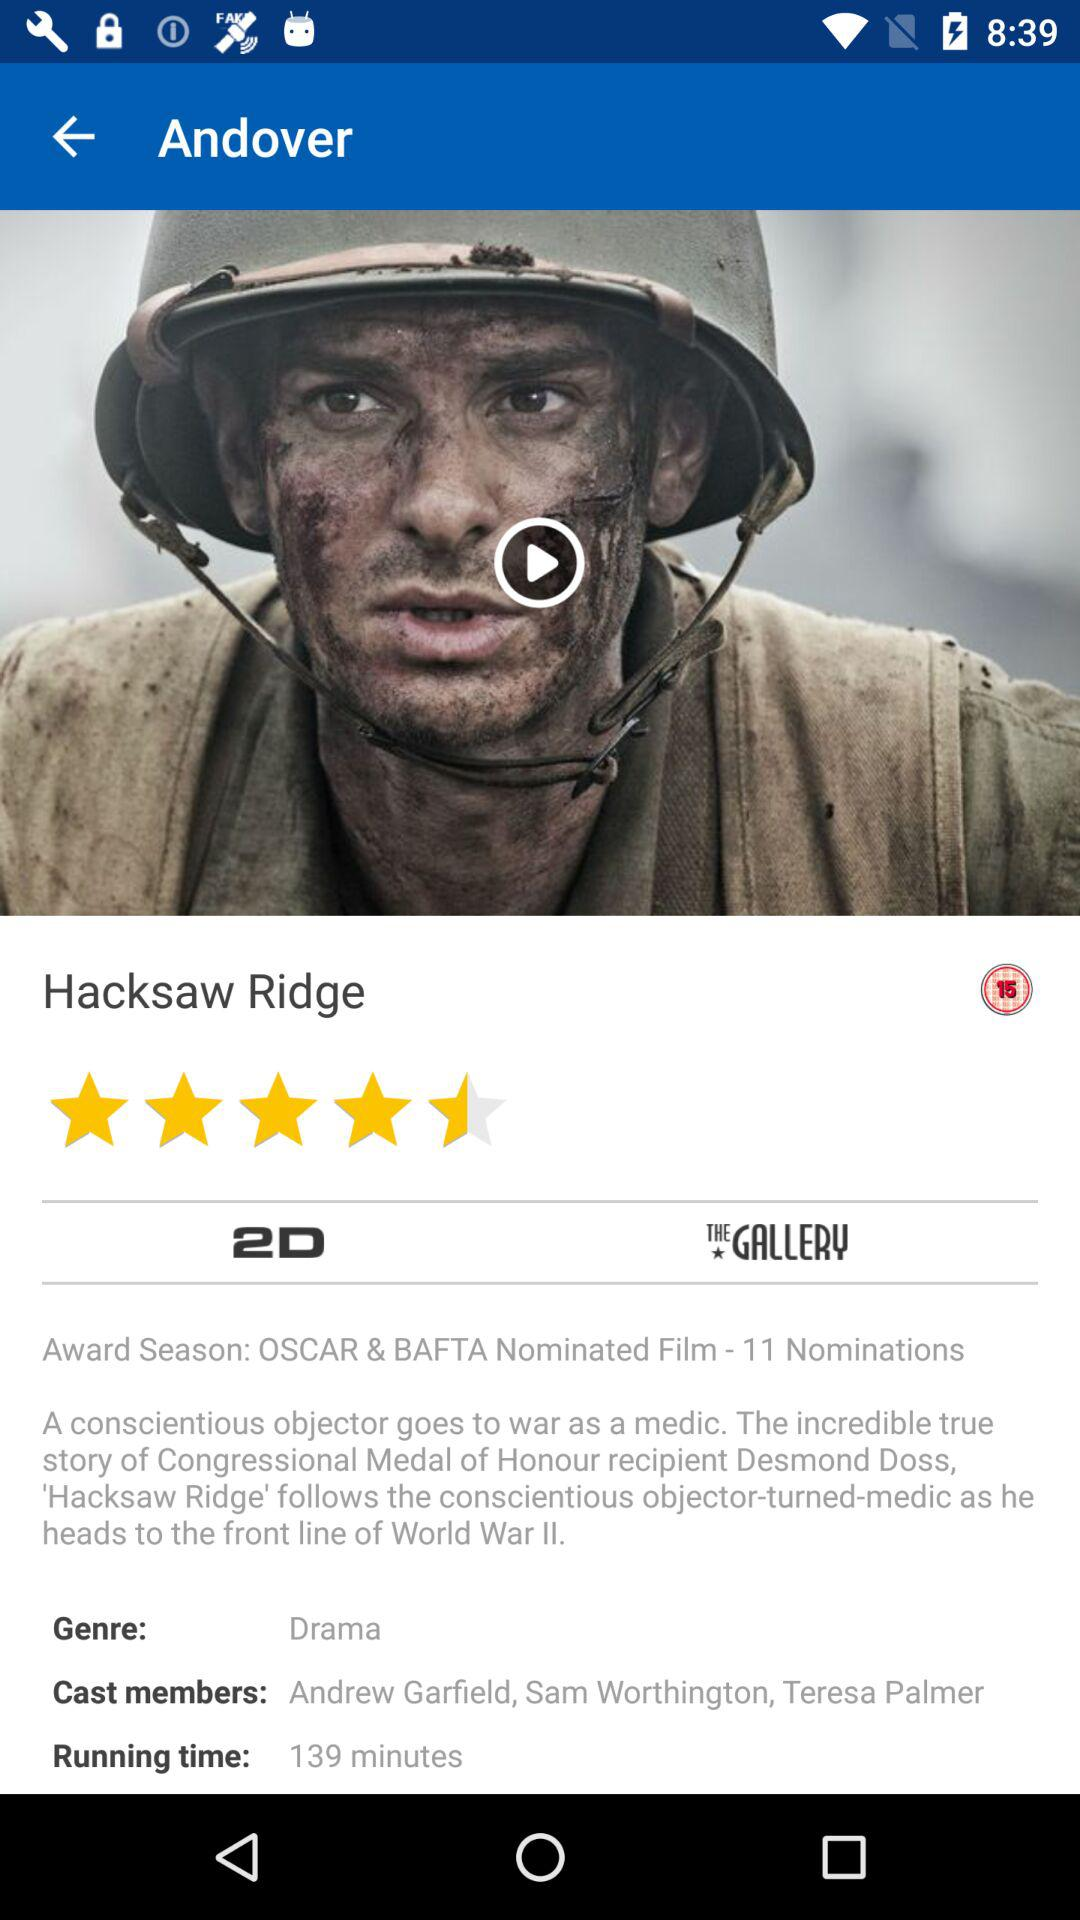What are the names of the cast members? The names are Andrew Garfield, Sam Worthington and Teresa Palmer. 